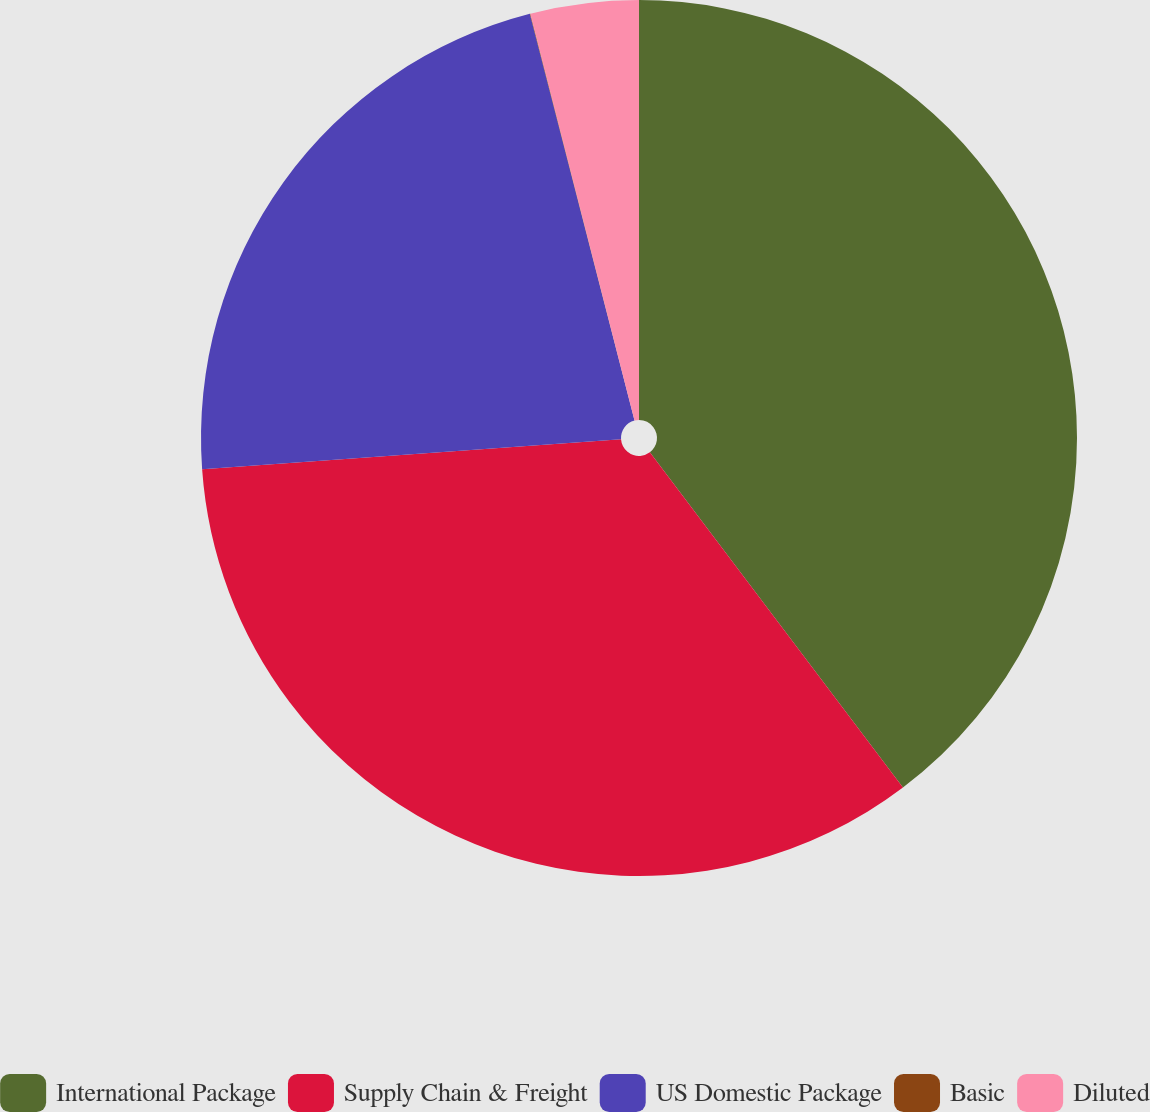Convert chart to OTSL. <chart><loc_0><loc_0><loc_500><loc_500><pie_chart><fcel>International Package<fcel>Supply Chain & Freight<fcel>US Domestic Package<fcel>Basic<fcel>Diluted<nl><fcel>39.71%<fcel>34.16%<fcel>22.13%<fcel>0.02%<fcel>3.99%<nl></chart> 